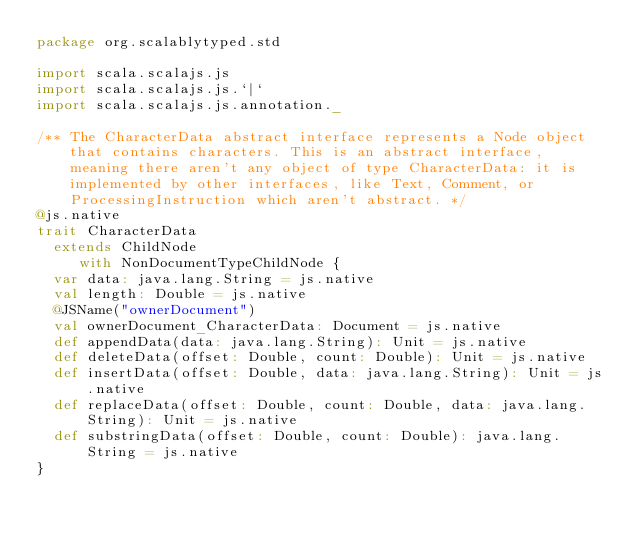<code> <loc_0><loc_0><loc_500><loc_500><_Scala_>package org.scalablytyped.std

import scala.scalajs.js
import scala.scalajs.js.`|`
import scala.scalajs.js.annotation._

/** The CharacterData abstract interface represents a Node object that contains characters. This is an abstract interface, meaning there aren't any object of type CharacterData: it is implemented by other interfaces, like Text, Comment, or ProcessingInstruction which aren't abstract. */
@js.native
trait CharacterData
  extends ChildNode
     with NonDocumentTypeChildNode {
  var data: java.lang.String = js.native
  val length: Double = js.native
  @JSName("ownerDocument")
  val ownerDocument_CharacterData: Document = js.native
  def appendData(data: java.lang.String): Unit = js.native
  def deleteData(offset: Double, count: Double): Unit = js.native
  def insertData(offset: Double, data: java.lang.String): Unit = js.native
  def replaceData(offset: Double, count: Double, data: java.lang.String): Unit = js.native
  def substringData(offset: Double, count: Double): java.lang.String = js.native
}

</code> 